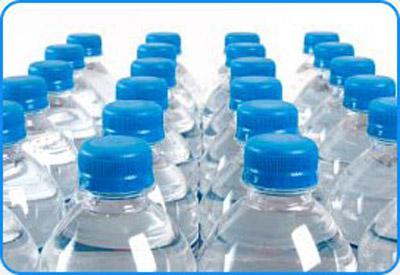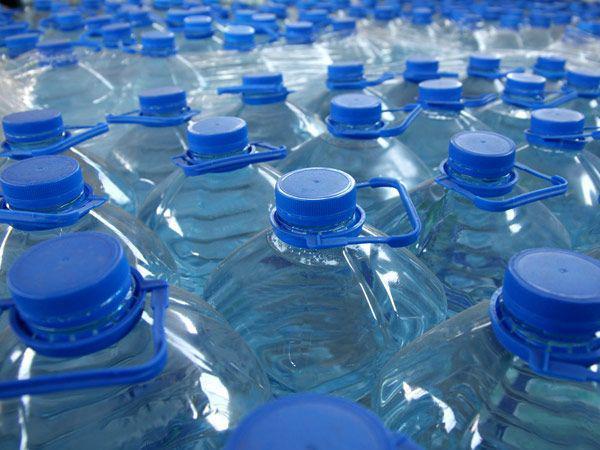The first image is the image on the left, the second image is the image on the right. Considering the images on both sides, is "In 1 of the images, the bottles have large rectangular reflections." valid? Answer yes or no. Yes. 